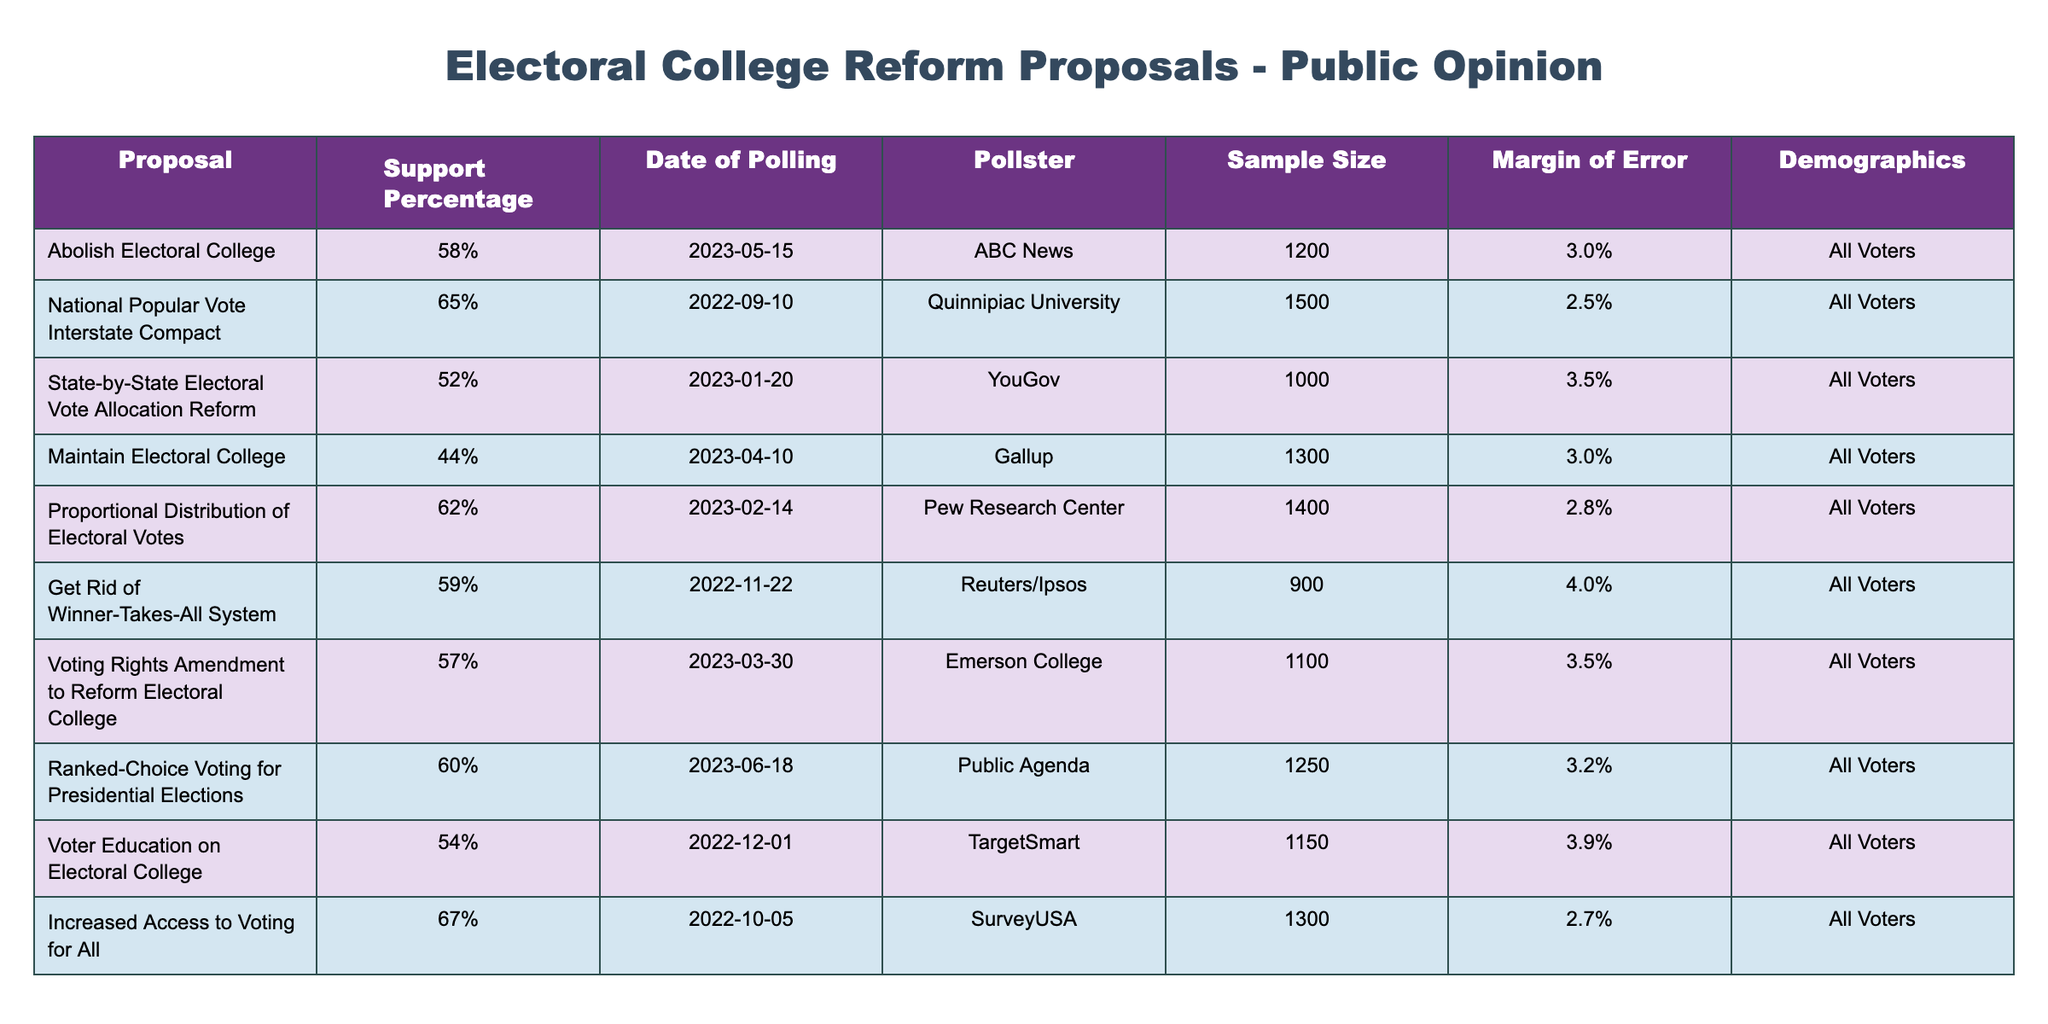What is the support percentage for abolishing the Electoral College? The table shows that the support percentage for abolishing the Electoral College is 58%. This value can be found directly in the 'Support Percentage' column corresponding to the 'Abolish Electoral College' proposal.
Answer: 58% Which proposal has the highest support percentage among the listed options? By examining the 'Support Percentage' column, the proposal with the highest percentage is the 'Increased Access to Voting for All' with a support percentage of 67%. This can be confirmed by comparing all the values in that column.
Answer: Increased Access to Voting for All How many proposals have a support percentage of 60% or more? The table lists 5 proposals with a support percentage of 60% or more: National Popular Vote Interstate Compact (65%), Increased Access to Voting for All (67%), Proportional Distribution of Electoral Votes (62%), Ranked-Choice Voting for Presidential Elections (60%), and Get Rid of Winner-Takes-All System (59%). Counting these gives 5.
Answer: 5 What is the average support percentage for all the proposals listed? To find the average support percentage, we first convert all percentages to numeric values: 58, 65, 52, 44, 62, 59, 57, 60, 54, 67. Summing them gives 605. There are 10 proposals, so the average is 605 / 10 = 60.5.
Answer: 60.5 Is the support for the National Popular Vote Interstate Compact greater than the support for maintaining the Electoral College? The support for the National Popular Vote Interstate Compact is 65%, while the support for maintaining the Electoral College is 44%. Since 65% is greater than 44%, the statement is true.
Answer: Yes Which demographic did all proposals in the table target? The 'Demographics' column indicates that all proposals targeted 'All Voters'. This is consistent across all entries without exceptions.
Answer: All Voters What is the support percentage difference between the proposal to maintain the Electoral College and the proposal to get rid of the Winner-Takes-All system? The support percentage for maintaining the Electoral College is 44%, while for getting rid of the Winner-Takes-All system, it is 59%. The difference is 59 - 44 = 15%.
Answer: 15% Which pollster conducted the polling for the proposal to abolish the Electoral College? The pollster listed for the 'Abolish Electoral College' proposal is ABC News, which can be found in the 'Pollster' column corresponding to that proposal.
Answer: ABC News What is the margin of error for the polling data regarding the Proportional Distribution of Electoral Votes? The margin of error for the Proportional Distribution of Electoral Votes is 2.8%, which is indicated in the 'Margin of Error' column for that specific proposal.
Answer: 2.8% 